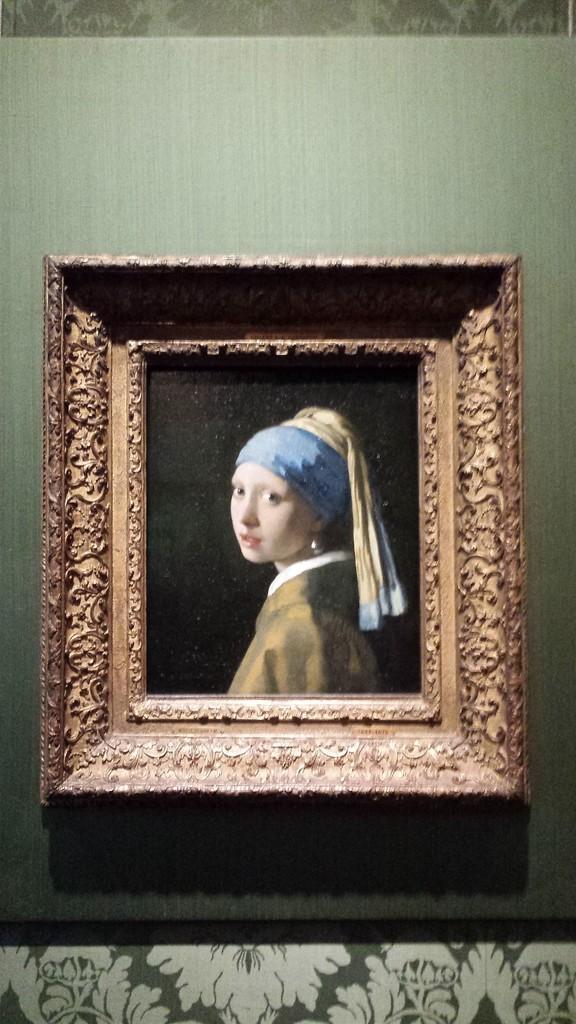In one or two sentences, can you explain what this image depicts? In this image, we can see the frame of a woman on the wall. 